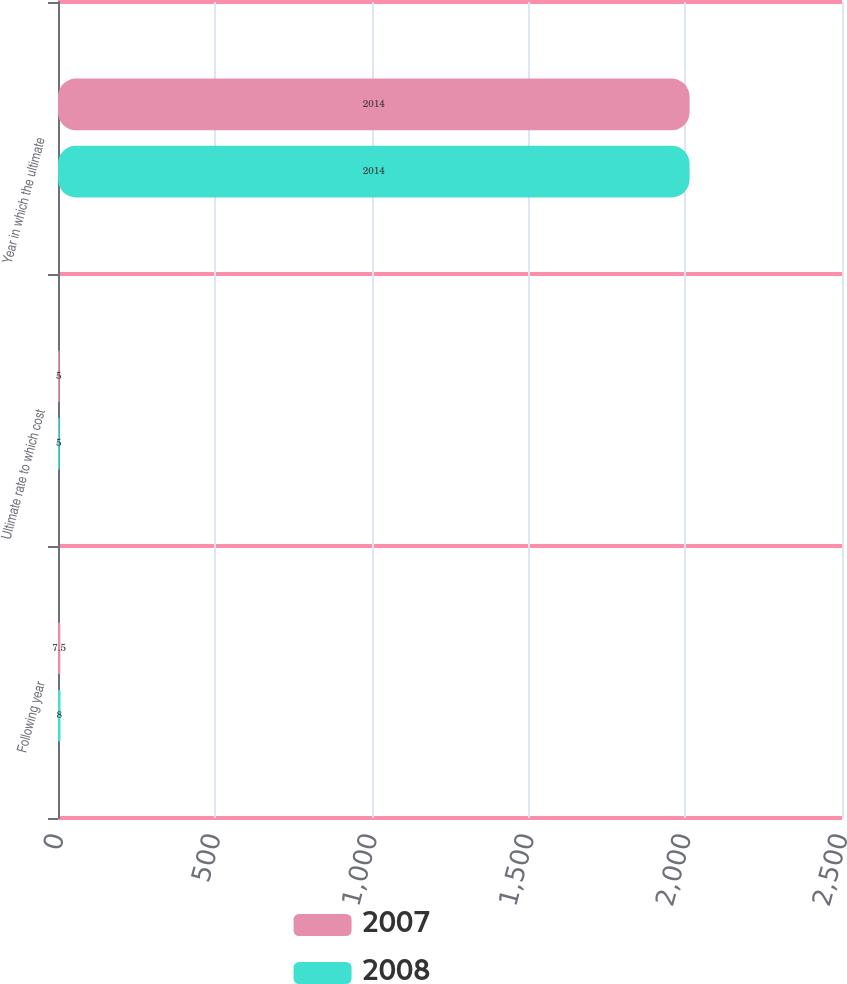Convert chart. <chart><loc_0><loc_0><loc_500><loc_500><stacked_bar_chart><ecel><fcel>Following year<fcel>Ultimate rate to which cost<fcel>Year in which the ultimate<nl><fcel>2007<fcel>7.5<fcel>5<fcel>2014<nl><fcel>2008<fcel>8<fcel>5<fcel>2014<nl></chart> 